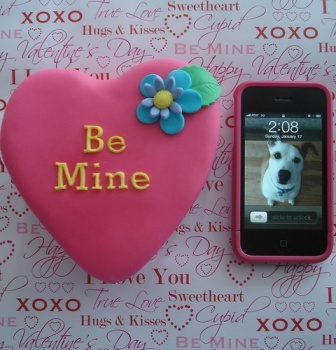What might the inclusion of the iPhone and the dog's image on its screen suggest about the owner? The iPhone with the dog's image on its screen suggests that the owner holds a special affection for their pet, viewing it as a significant part of their life, much like a family member or a loved one. This inclusion in a Valentine-themed setting might imply that the owner cherishes the companionship the pet offers, equating it to the kinds of relationships typically celebrated on this day. It subtly highlights the diverse forms that love can take, extending beyond just romantic attachments. 